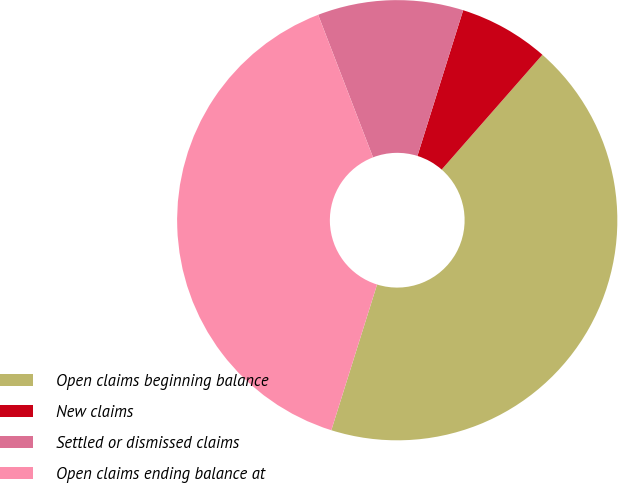Convert chart to OTSL. <chart><loc_0><loc_0><loc_500><loc_500><pie_chart><fcel>Open claims beginning balance<fcel>New claims<fcel>Settled or dismissed claims<fcel>Open claims ending balance at<nl><fcel>43.38%<fcel>6.62%<fcel>10.69%<fcel>39.31%<nl></chart> 